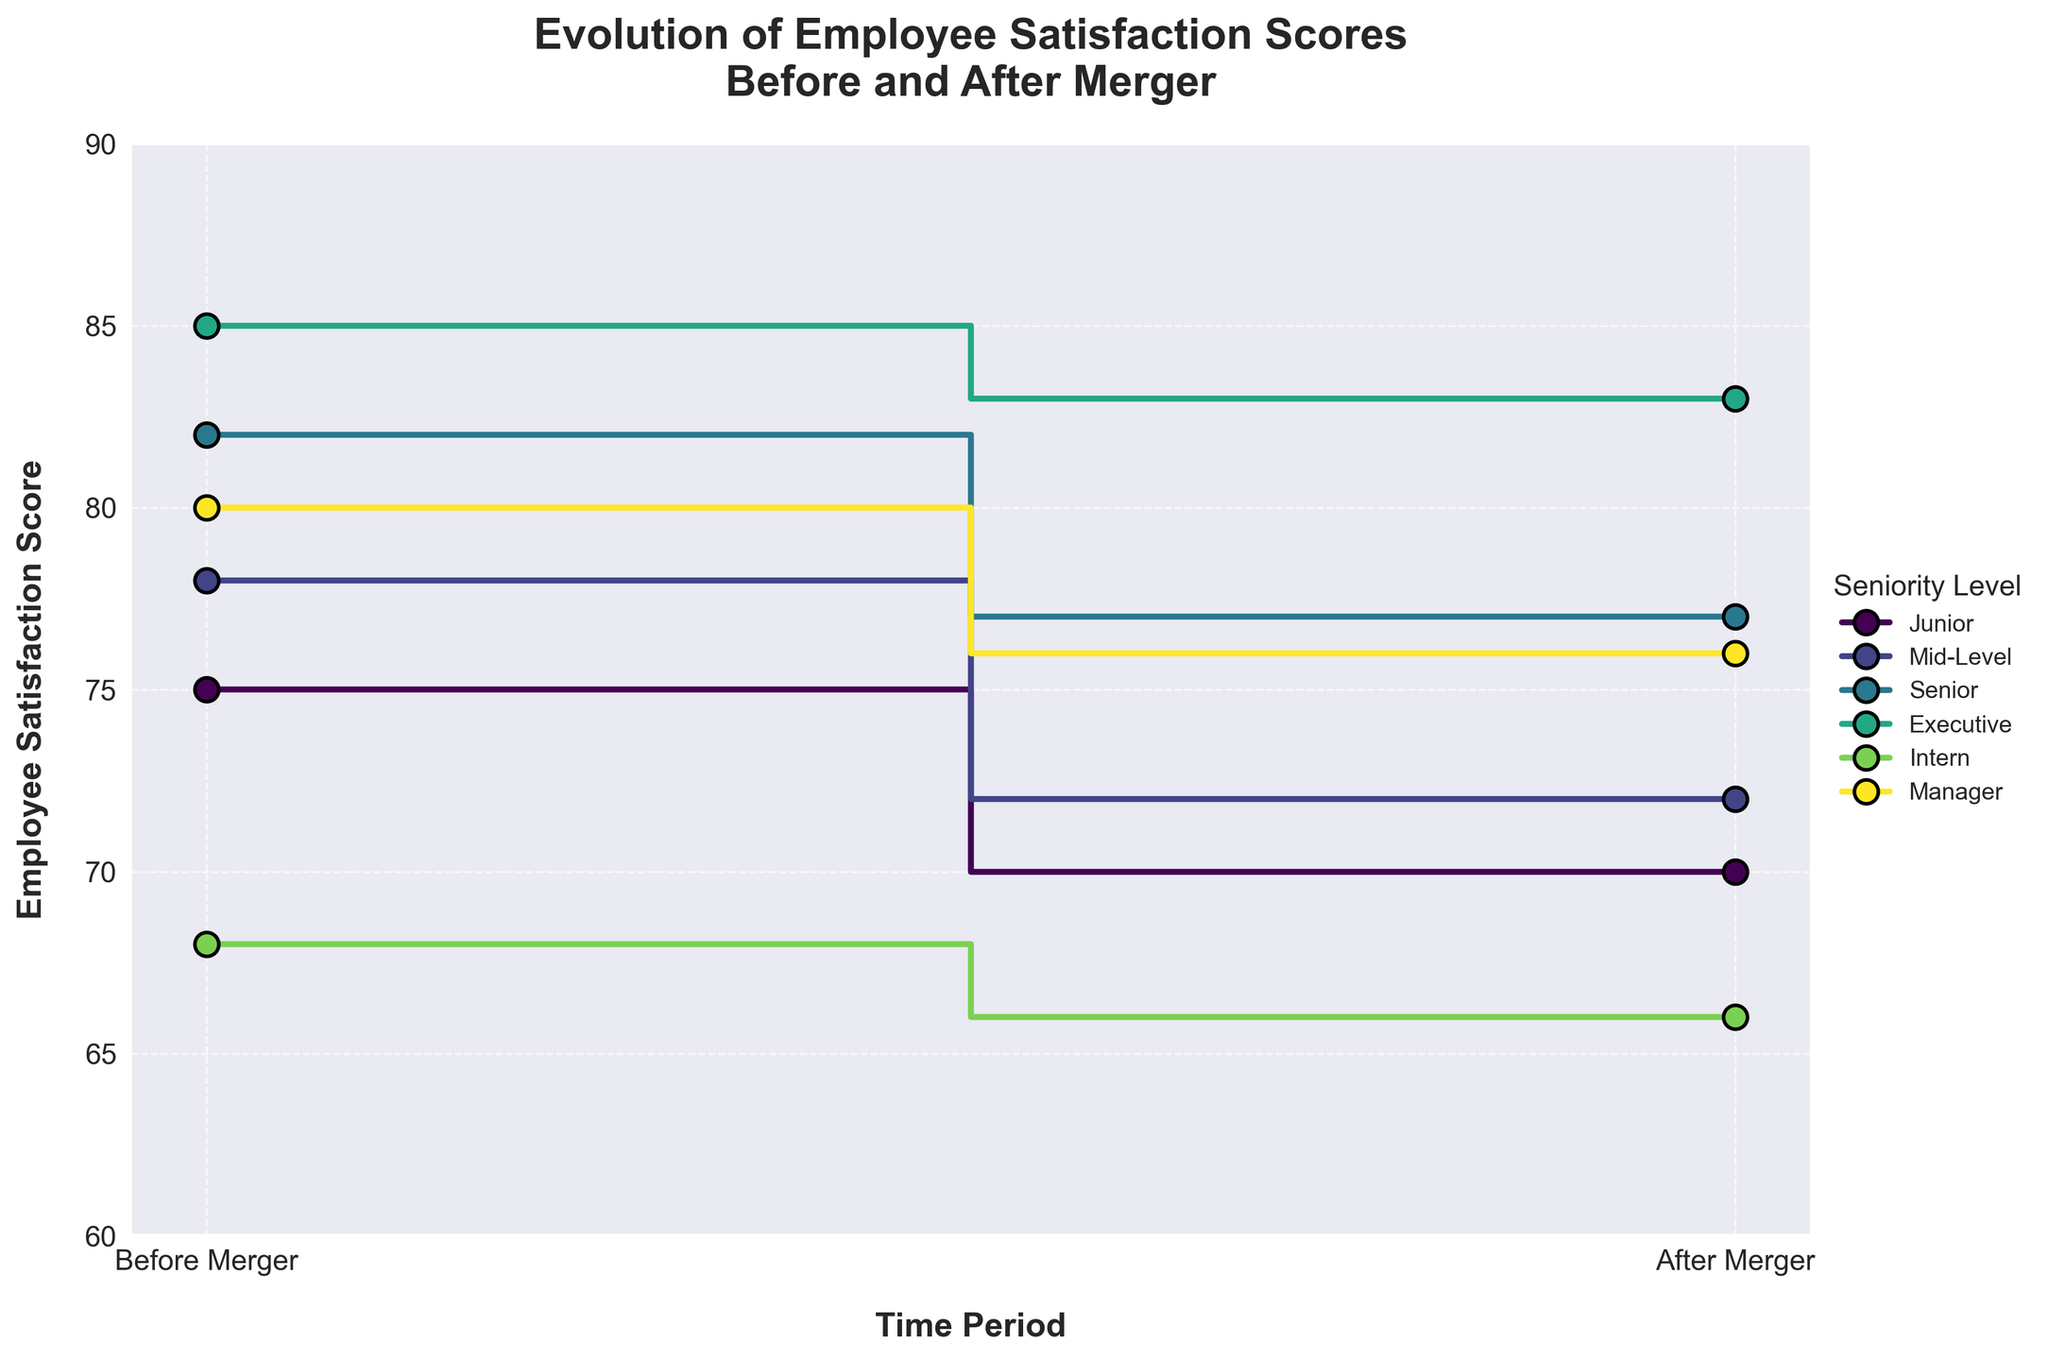**What's the title of the figure?** The title is located at the very top of the figure and usually provides a summary of what the plot is about. Read the text centered above the plot area.
Answer: Evolution of Employee Satisfaction Scores Before and After Merger **How many seniority levels are displayed in the figure?** Count the unique categories in the legend, which represents the different seniority levels being tracked over time.
Answer: Six **Which seniority level shows the smallest decrease in employee satisfaction score after the merger?** To determine this, compare the differences of before and after scores for each seniority level. The level with the smallest numerical difference is the one with the smallest decrease. Calculate: Junior (5), Mid-Level (6), Senior (5), Executive (2), Intern (2), Manager (4). The level with the smallest decrease is the Executive and Intern with a decrease of 2 points.
Answer: Executive and Intern **Which seniority level had the highest employee satisfaction score before the merger?** Compare all the employee satisfaction scores before the merger for each seniority level. Identify the highest value among them: Junior (75), Mid-Level (78), Senior (82), Executive (85), Intern (68), Manager (80). The highest score before the merger is for the Executive level.
Answer: Executive **Did any seniority level have a higher employee satisfaction score after the merger compared to before the merger?** Assess each seniority level by examining if their satisfaction score after the merger is higher than before. Check the data: Junior (75 to 70 - No), Mid-Level (78 to 72 - No), Senior (82 to 77 - No), Executive (85 to 83 - No), Intern (68 to 66 - No), Manager (80 to 76 - No). No seniority level had a higher score after the merger.
Answer: No **What is the average decrease in employee satisfaction scores across all seniority levels after the merger?** To calculate the average decrease: find the score differences for each seniority level, sum them up, and divide by the number of levels. Calculate: (75 - 70) + (78 - 72) + (82 - 77) + (85 - 83) + (68 - 66) + (80 - 76) = 5 + 6 + 5 + 2 + 2 + 4 = 24. There are 6 levels, so the average decrease is 24 / 6 = 4.
Answer: 4 **Which seniority level had the smallest satisfaction score before the merger, and what was the value?** Compare all the employee satisfaction scores before the merger for each seniority level. Identify the smallest value among them: Junior (75), Mid-Level (78), Senior (82), Executive (85), Intern (68), Manager (80). The smallest score before the merger is for Intern at 68.
Answer: Intern, 68 **What is the overall trend in employee satisfaction scores after the merger for all seniority levels?** The trend can be determined by observing whether most scores increased or decreased. Examine the after-merger scores compared to before-merger scores for all levels: all seniority levels show a decrease in satisfaction score. Therefore, the overall trend is a decrease.
Answer: Decrease 